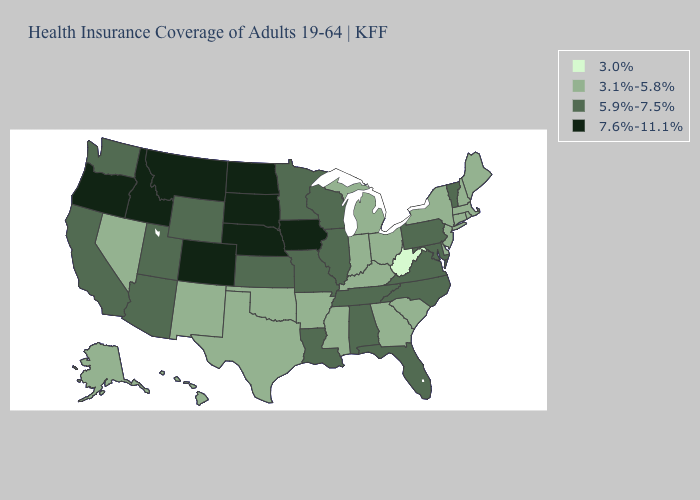What is the value of Illinois?
Write a very short answer. 5.9%-7.5%. Among the states that border Maryland , does West Virginia have the lowest value?
Keep it brief. Yes. Among the states that border Vermont , which have the highest value?
Write a very short answer. Massachusetts, New Hampshire, New York. Among the states that border Idaho , does Montana have the highest value?
Answer briefly. Yes. Does Nevada have a higher value than Kansas?
Give a very brief answer. No. Name the states that have a value in the range 5.9%-7.5%?
Keep it brief. Alabama, Arizona, California, Florida, Illinois, Kansas, Louisiana, Maryland, Minnesota, Missouri, North Carolina, Pennsylvania, Tennessee, Utah, Vermont, Virginia, Washington, Wisconsin, Wyoming. Does Oregon have the lowest value in the USA?
Write a very short answer. No. What is the value of New Mexico?
Answer briefly. 3.1%-5.8%. Among the states that border Kentucky , does Ohio have the lowest value?
Give a very brief answer. No. What is the value of Georgia?
Write a very short answer. 3.1%-5.8%. Name the states that have a value in the range 7.6%-11.1%?
Answer briefly. Colorado, Idaho, Iowa, Montana, Nebraska, North Dakota, Oregon, South Dakota. What is the value of North Dakota?
Concise answer only. 7.6%-11.1%. What is the lowest value in states that border Wyoming?
Concise answer only. 5.9%-7.5%. Among the states that border New Mexico , which have the lowest value?
Give a very brief answer. Oklahoma, Texas. Name the states that have a value in the range 3.1%-5.8%?
Short answer required. Alaska, Arkansas, Connecticut, Delaware, Georgia, Hawaii, Indiana, Kentucky, Maine, Massachusetts, Michigan, Mississippi, Nevada, New Hampshire, New Jersey, New Mexico, New York, Ohio, Oklahoma, Rhode Island, South Carolina, Texas. 